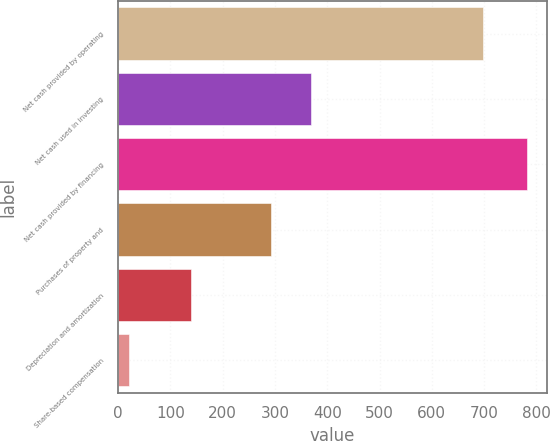Convert chart. <chart><loc_0><loc_0><loc_500><loc_500><bar_chart><fcel>Net cash provided by operating<fcel>Net cash used in investing<fcel>Net cash provided by financing<fcel>Purchases of property and<fcel>Depreciation and amortization<fcel>Share-based compensation<nl><fcel>698<fcel>369.1<fcel>781<fcel>293<fcel>139<fcel>20<nl></chart> 